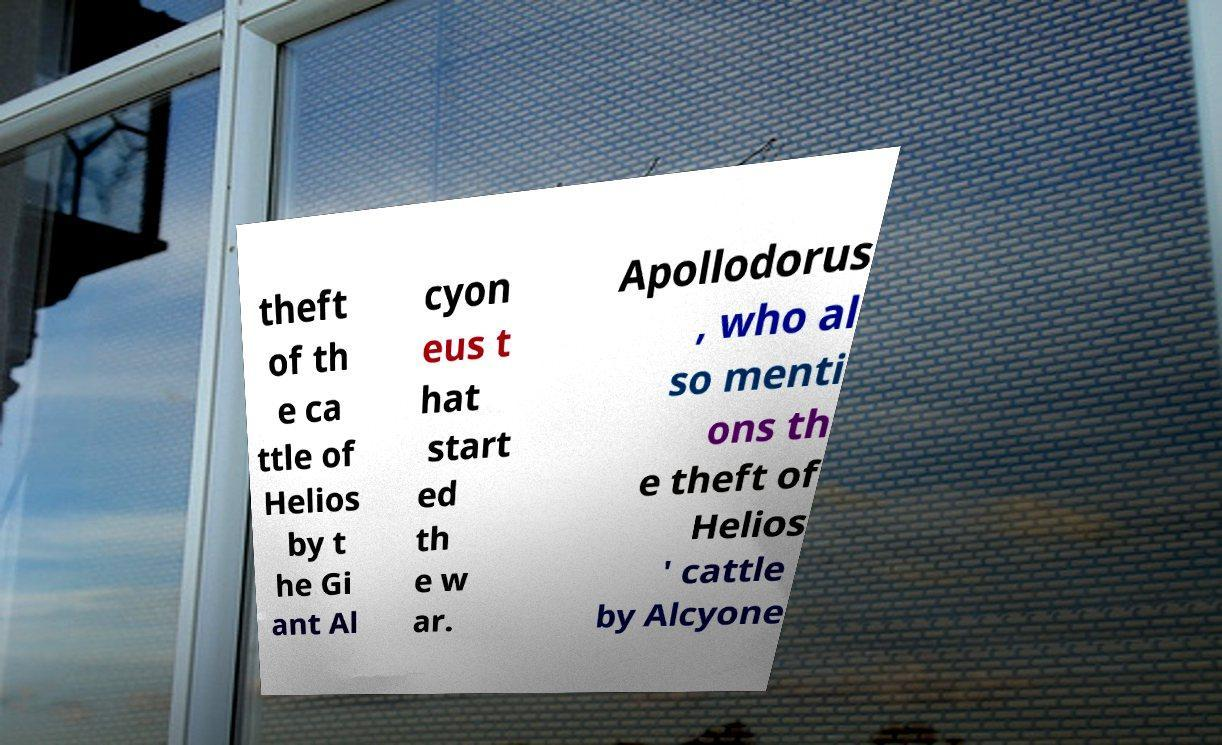Could you assist in decoding the text presented in this image and type it out clearly? theft of th e ca ttle of Helios by t he Gi ant Al cyon eus t hat start ed th e w ar. Apollodorus , who al so menti ons th e theft of Helios ' cattle by Alcyone 